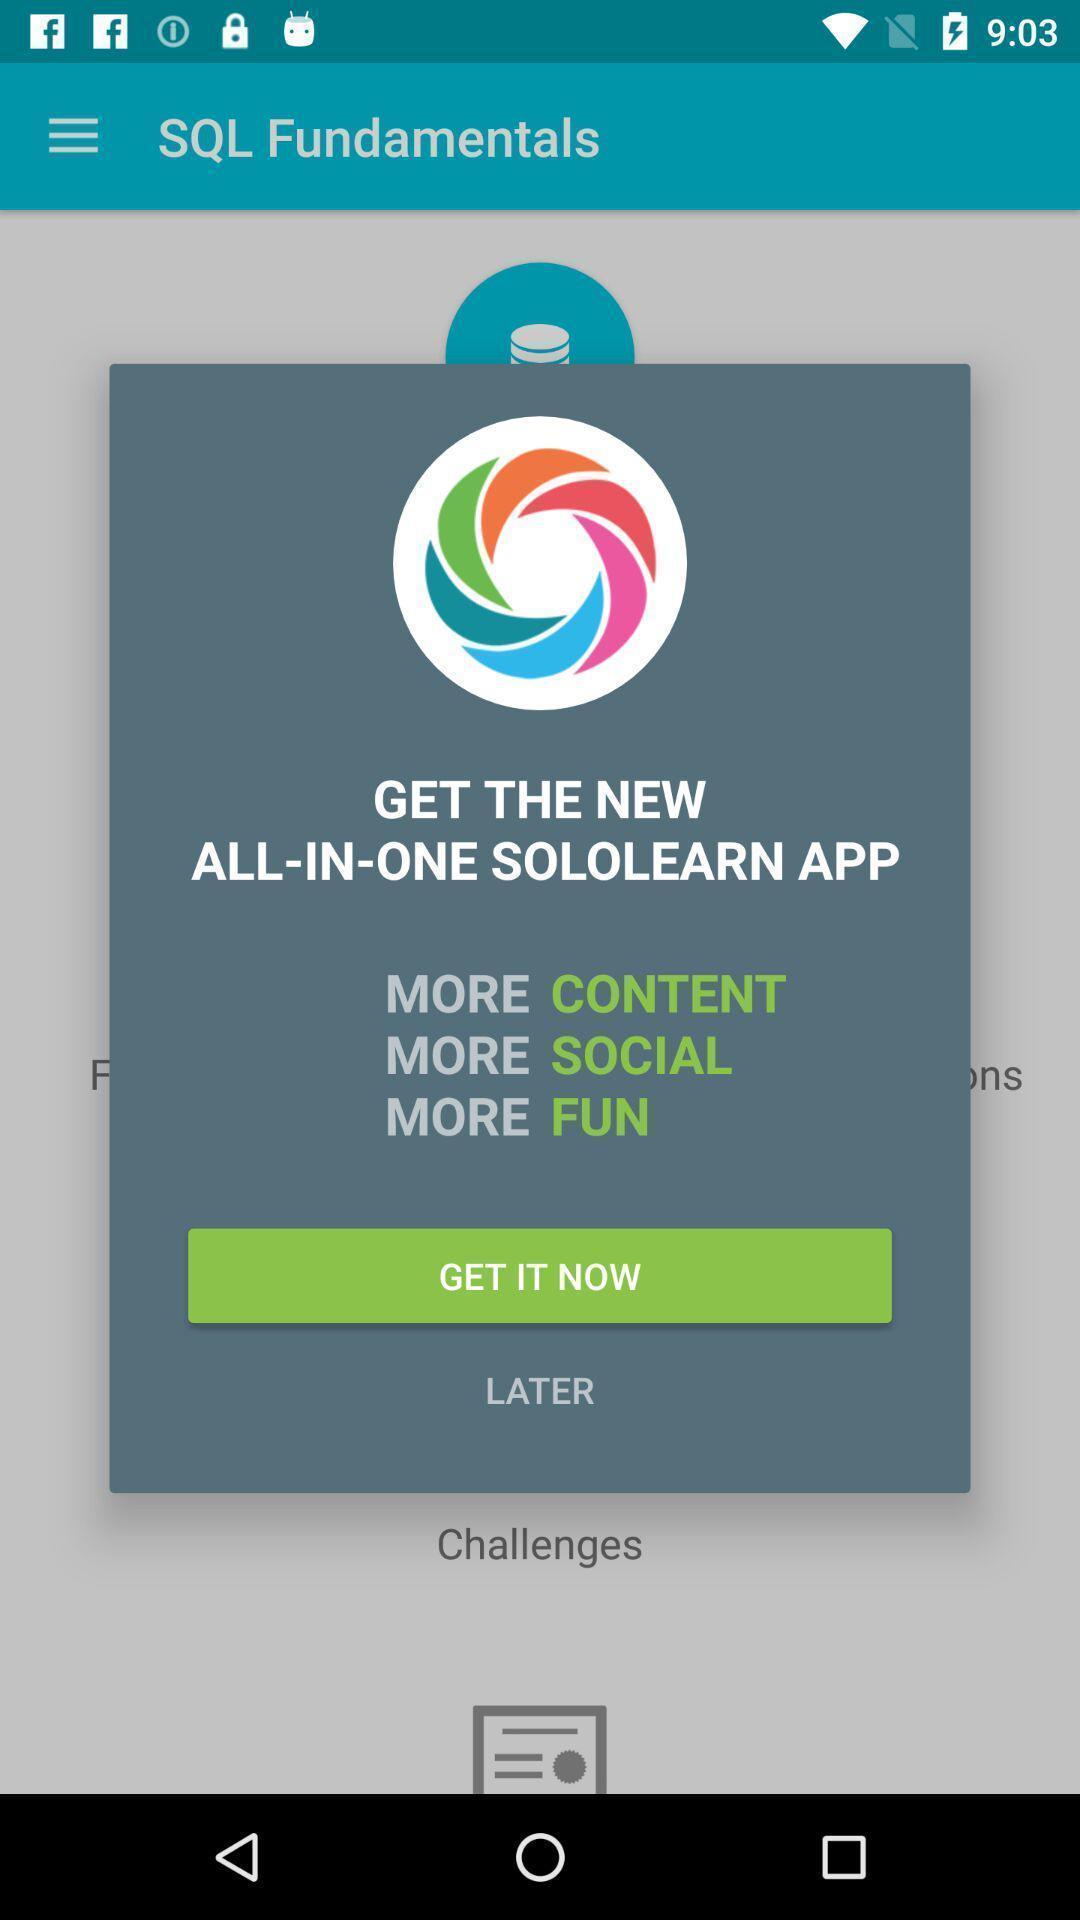What can you discern from this picture? Popup of application to install. 